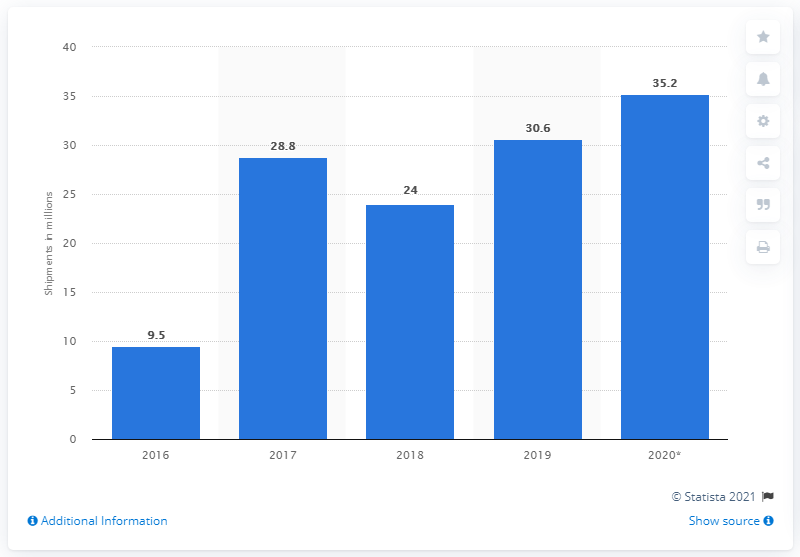Specify some key components in this picture. In 2020, it is projected that approximately 35.2 smart home device units will be shipped. 